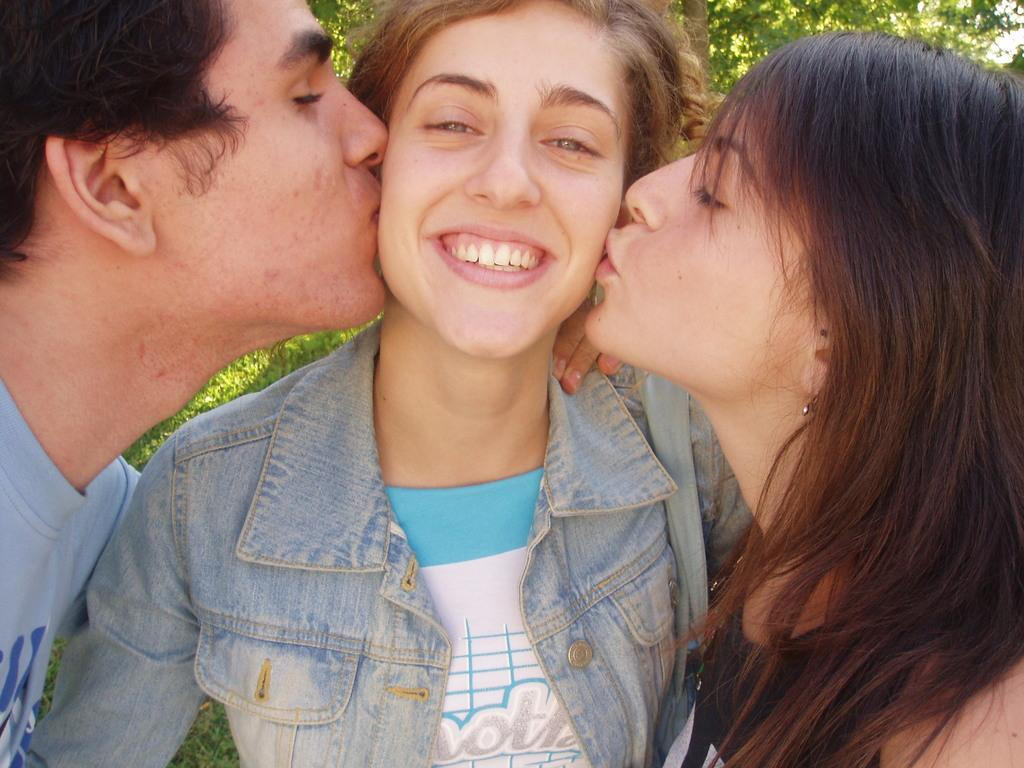What can be seen in the front of the image? There are persons standing in the front of the image. Can you describe the woman's position in the image? A woman is standing in the center of the image. What is the woman's facial expression in the image? The woman is smiling. What type of natural scenery is visible in the background of the image? There are trees in the background of the image. What type of hospital can be seen in the image? There is no hospital present in the image. Can you tell me how many tickets the woman is holding in the image? There is no mention of tickets in the image, so it cannot be determined how many the woman might be holding. 